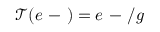<formula> <loc_0><loc_0><loc_500><loc_500>\mathcal { T } ( e - ) = e - / g</formula> 